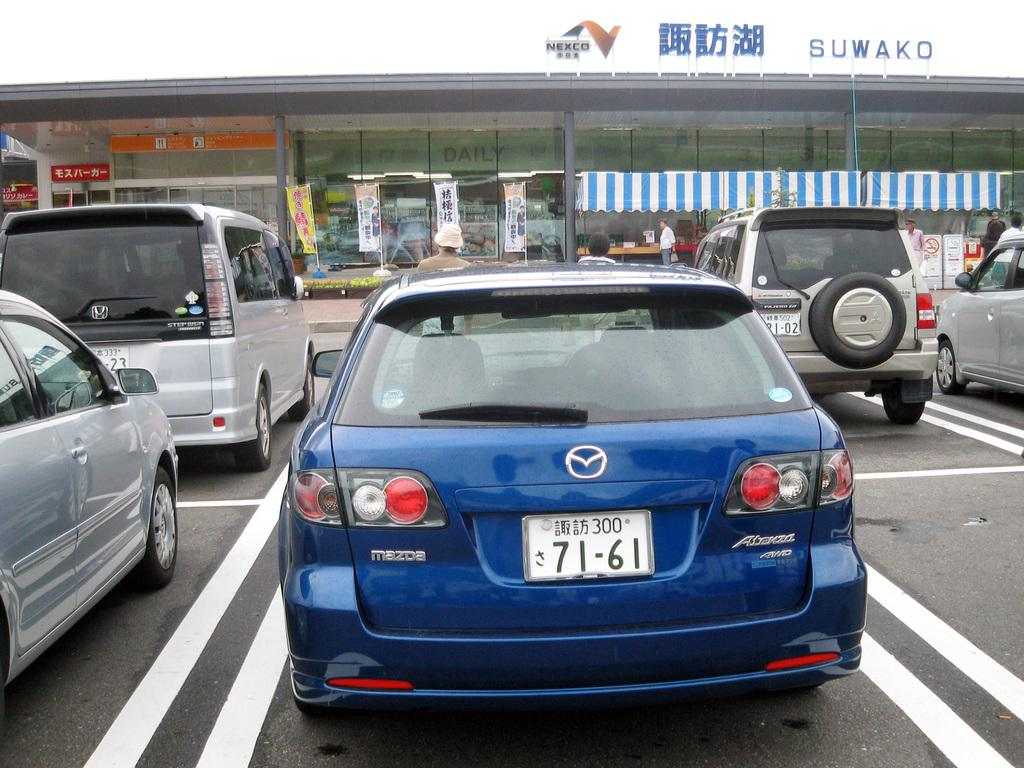What can be seen in the image that is used for transportation? There are vehicles parked in the image. What structure is visible in the background of the image? There is a building in the background of the image. What is written on the building in the image? The building has a name board. What are the poles in the image used for? The poles in the image have flags on them. What is the condition of the sky in the image? The sky is clear in the image. Can you see any sea creatures swimming in the image? There is no sea or sea creatures present in the image. What type of nut is being used as a chess piece in the image? There is no chess or nut present in the image. 